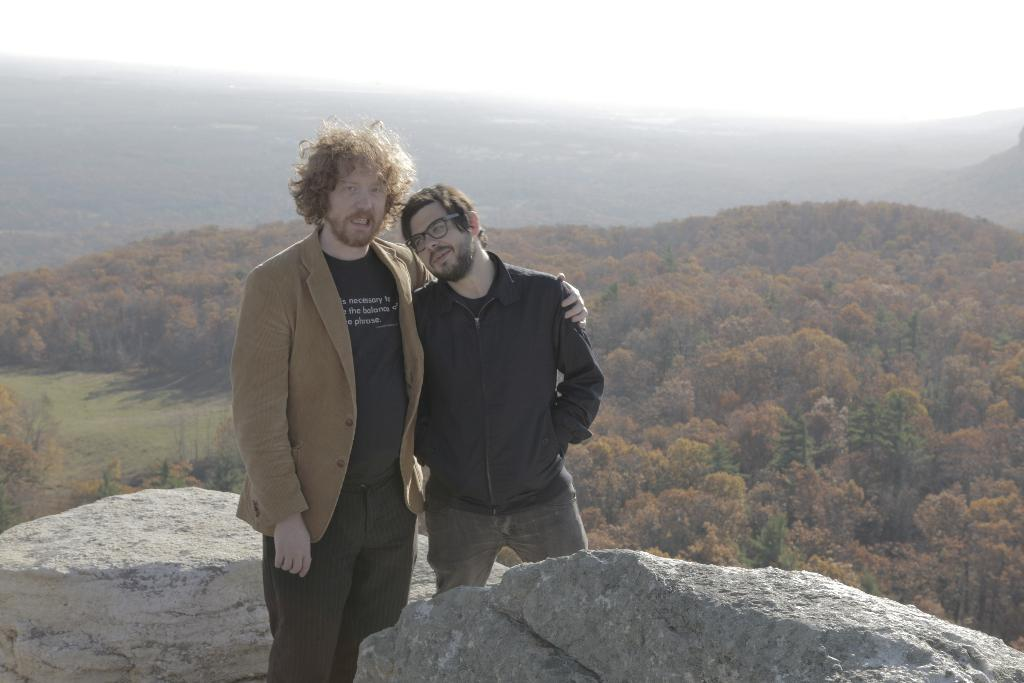How many people are in the foreground of the image? There are two men in the foreground of the image. What are the men standing near in the image? The men are standing between two rocks in the image. What can be seen in the background of the image? There are trees and mountains in the background of the image. What is the source of the white shade visible at the top of the image? The white shade visible at the top of the image is likely due to clouds or fog. What type of writing can be seen on the rocks in the image? There is no writing visible on the rocks in the image. What type of lumber is being used to construct the mountains in the image? The mountains in the image are natural formations and do not involve the use of lumber. 